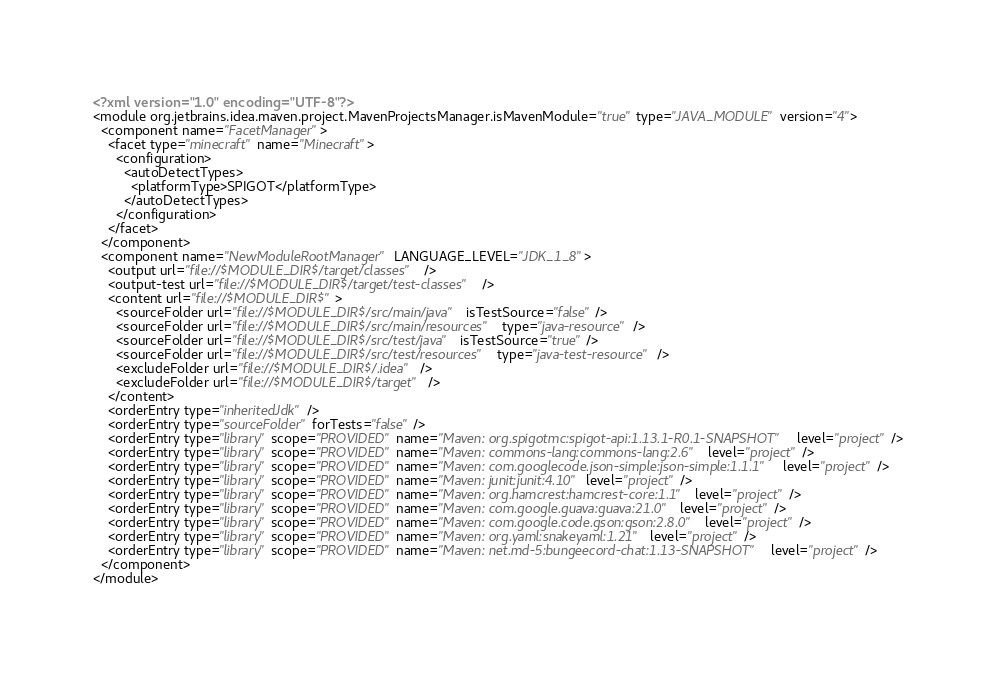Convert code to text. <code><loc_0><loc_0><loc_500><loc_500><_XML_><?xml version="1.0" encoding="UTF-8"?>
<module org.jetbrains.idea.maven.project.MavenProjectsManager.isMavenModule="true" type="JAVA_MODULE" version="4">
  <component name="FacetManager">
    <facet type="minecraft" name="Minecraft">
      <configuration>
        <autoDetectTypes>
          <platformType>SPIGOT</platformType>
        </autoDetectTypes>
      </configuration>
    </facet>
  </component>
  <component name="NewModuleRootManager" LANGUAGE_LEVEL="JDK_1_8">
    <output url="file://$MODULE_DIR$/target/classes" />
    <output-test url="file://$MODULE_DIR$/target/test-classes" />
    <content url="file://$MODULE_DIR$">
      <sourceFolder url="file://$MODULE_DIR$/src/main/java" isTestSource="false" />
      <sourceFolder url="file://$MODULE_DIR$/src/main/resources" type="java-resource" />
      <sourceFolder url="file://$MODULE_DIR$/src/test/java" isTestSource="true" />
      <sourceFolder url="file://$MODULE_DIR$/src/test/resources" type="java-test-resource" />
      <excludeFolder url="file://$MODULE_DIR$/.idea" />
      <excludeFolder url="file://$MODULE_DIR$/target" />
    </content>
    <orderEntry type="inheritedJdk" />
    <orderEntry type="sourceFolder" forTests="false" />
    <orderEntry type="library" scope="PROVIDED" name="Maven: org.spigotmc:spigot-api:1.13.1-R0.1-SNAPSHOT" level="project" />
    <orderEntry type="library" scope="PROVIDED" name="Maven: commons-lang:commons-lang:2.6" level="project" />
    <orderEntry type="library" scope="PROVIDED" name="Maven: com.googlecode.json-simple:json-simple:1.1.1" level="project" />
    <orderEntry type="library" scope="PROVIDED" name="Maven: junit:junit:4.10" level="project" />
    <orderEntry type="library" scope="PROVIDED" name="Maven: org.hamcrest:hamcrest-core:1.1" level="project" />
    <orderEntry type="library" scope="PROVIDED" name="Maven: com.google.guava:guava:21.0" level="project" />
    <orderEntry type="library" scope="PROVIDED" name="Maven: com.google.code.gson:gson:2.8.0" level="project" />
    <orderEntry type="library" scope="PROVIDED" name="Maven: org.yaml:snakeyaml:1.21" level="project" />
    <orderEntry type="library" scope="PROVIDED" name="Maven: net.md-5:bungeecord-chat:1.13-SNAPSHOT" level="project" />
  </component>
</module></code> 